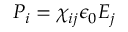Convert formula to latex. <formula><loc_0><loc_0><loc_500><loc_500>P _ { i } = \chi _ { i j } \epsilon _ { 0 } E _ { j }</formula> 